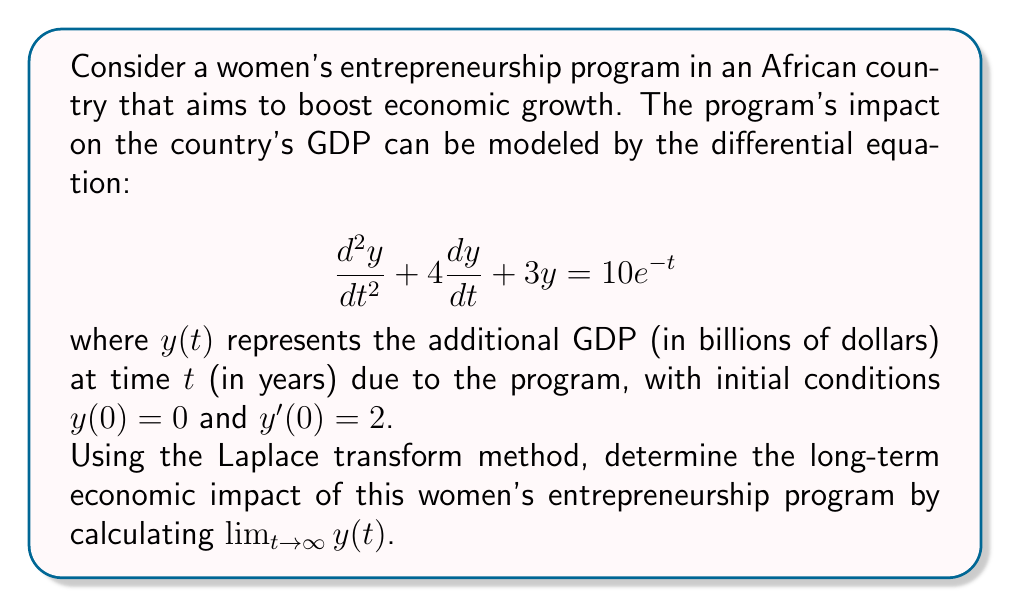Show me your answer to this math problem. Let's solve this step-by-step using the Laplace transform method:

1) Take the Laplace transform of both sides of the equation:
   $$\mathcal{L}\{y''(t) + 4y'(t) + 3y(t)\} = \mathcal{L}\{10e^{-t}\}$$

2) Using Laplace transform properties:
   $$s^2Y(s) - sy(0) - y'(0) + 4[sY(s) - y(0)] + 3Y(s) = \frac{10}{s+1}$$

3) Substitute the initial conditions $y(0) = 0$ and $y'(0) = 2$:
   $$s^2Y(s) - 2 + 4sY(s) + 3Y(s) = \frac{10}{s+1}$$

4) Rearrange terms:
   $$(s^2 + 4s + 3)Y(s) = \frac{10}{s+1} + 2$$

5) Solve for $Y(s)$:
   $$Y(s) = \frac{10}{(s+1)(s^2 + 4s + 3)} + \frac{2}{s^2 + 4s + 3}$$

6) Decompose into partial fractions:
   $$Y(s) = \frac{A}{s+1} + \frac{B}{s+1} + \frac{C}{s+3} + \frac{2}{(s+1)(s+3)}$$

7) Solve for $A$, $B$, and $C$ (details omitted for brevity):
   $$Y(s) = \frac{5}{(s+1)(s+3)} + \frac{5}{(s+1)^2} + \frac{2}{(s+1)(s+3)}$$

8) Take the inverse Laplace transform:
   $$y(t) = 5e^{-t} - 5e^{-3t} + 5te^{-t} + 2e^{-t} - 2e^{-3t}$$

9) Simplify:
   $$y(t) = (7 + 5t)e^{-t} - 7e^{-3t}$$

10) To find the long-term impact, calculate the limit as $t$ approaches infinity:
    $$\lim_{t \to \infty} y(t) = \lim_{t \to \infty} [(7 + 5t)e^{-t} - 7e^{-3t}] = 0$$

Therefore, the long-term economic impact of the women's entrepreneurship program approaches zero, indicating that while the program may have short-term benefits, its effect on GDP diminishes over time.
Answer: $\lim_{t \to \infty} y(t) = 0$ 